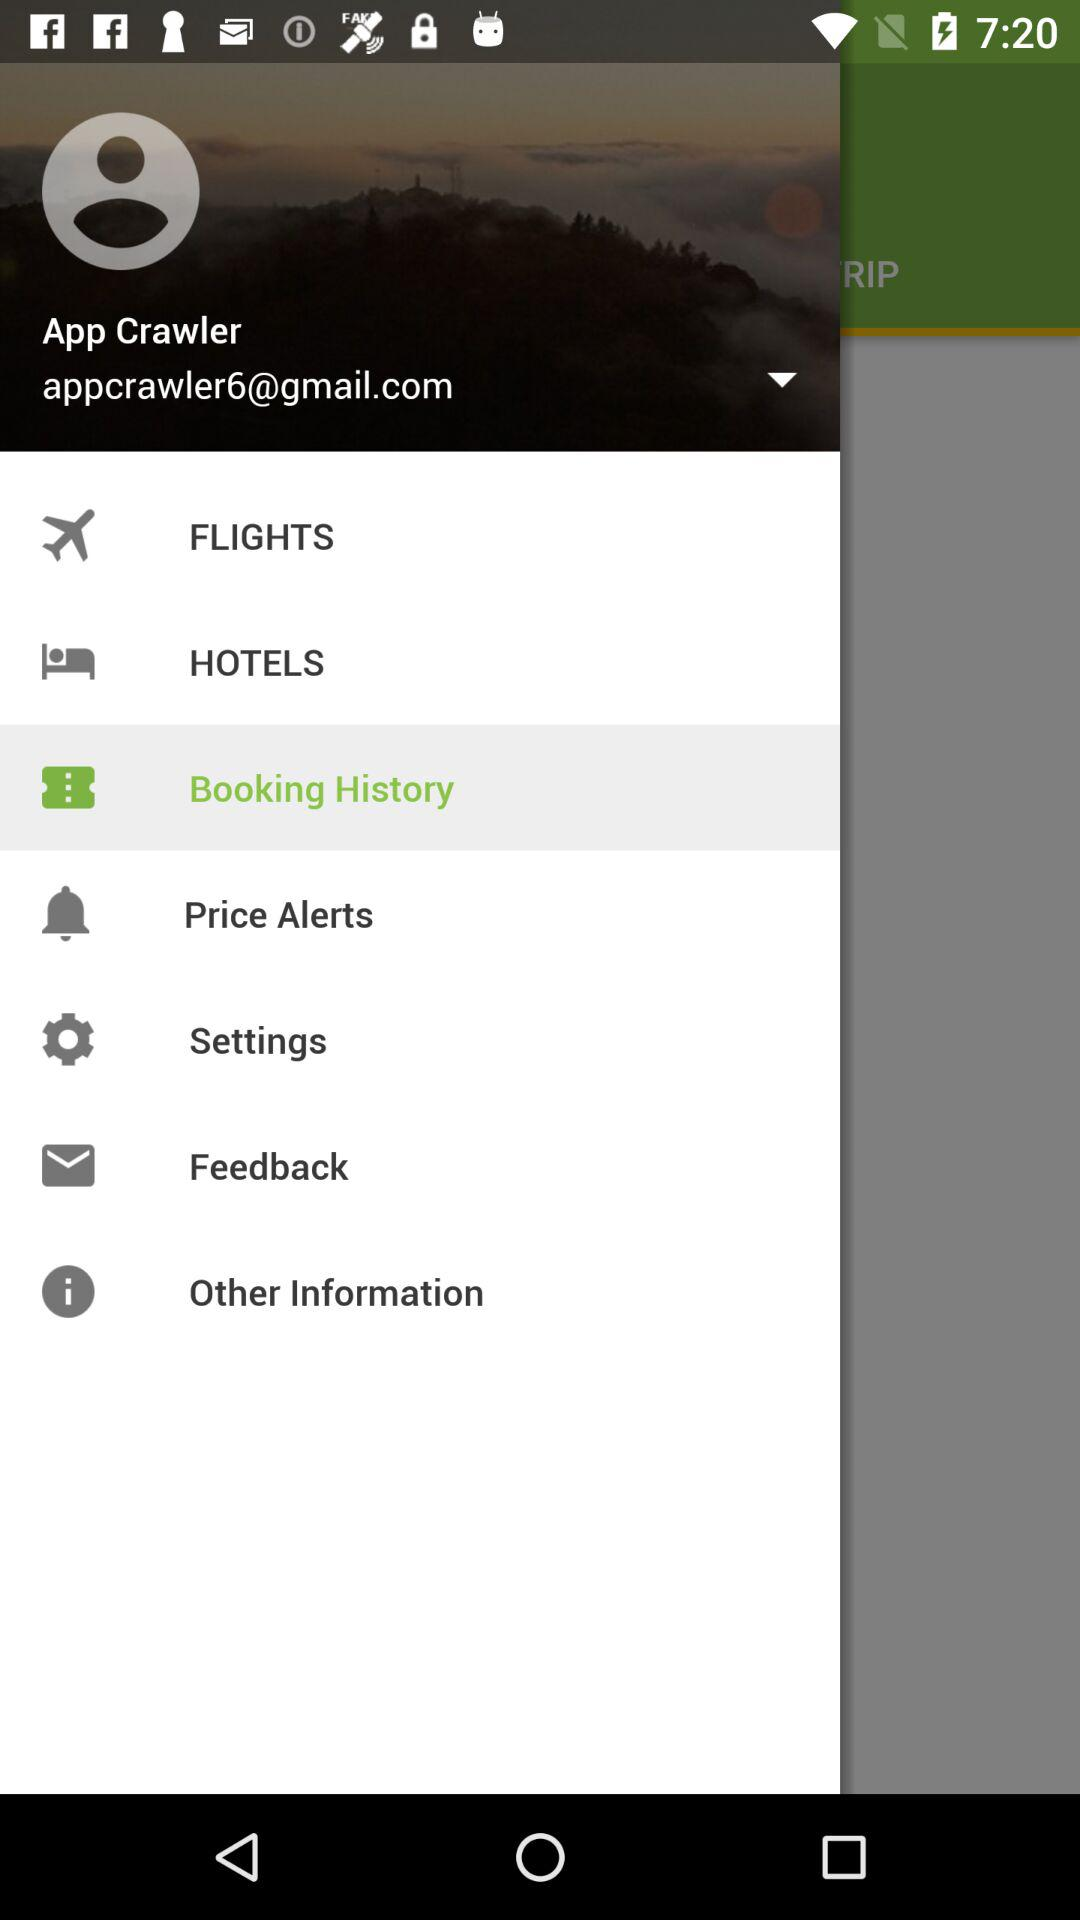What is the user name? The user name is App Crawler. 